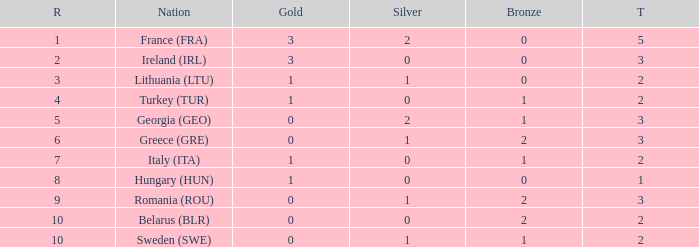What's the total of Sweden (SWE) having less than 1 silver? None. 